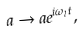<formula> <loc_0><loc_0><loc_500><loc_500>a \rightarrow a e ^ { i \omega _ { l } t } ,</formula> 